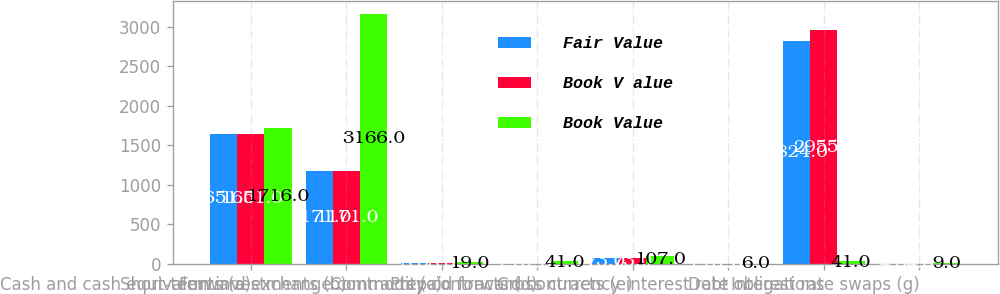Convert chart to OTSL. <chart><loc_0><loc_0><loc_500><loc_500><stacked_bar_chart><ecel><fcel>Cash and cash equivalents (a)<fcel>Short-term investments (b)<fcel>Forward exchange contracts (c)<fcel>Commodity contracts (d)<fcel>Prepaid forward contracts (e)<fcel>Cross currency interest rate<fcel>Debt obligations<fcel>Interest rate swaps (g)<nl><fcel>Fair Value<fcel>1651<fcel>1171<fcel>8<fcel>2<fcel>73<fcel>1<fcel>2824<fcel>4<nl><fcel>Book V alue<fcel>1651<fcel>1171<fcel>8<fcel>2<fcel>73<fcel>1<fcel>2955<fcel>4<nl><fcel>Book Value<fcel>1716<fcel>3166<fcel>19<fcel>41<fcel>107<fcel>6<fcel>41<fcel>9<nl></chart> 